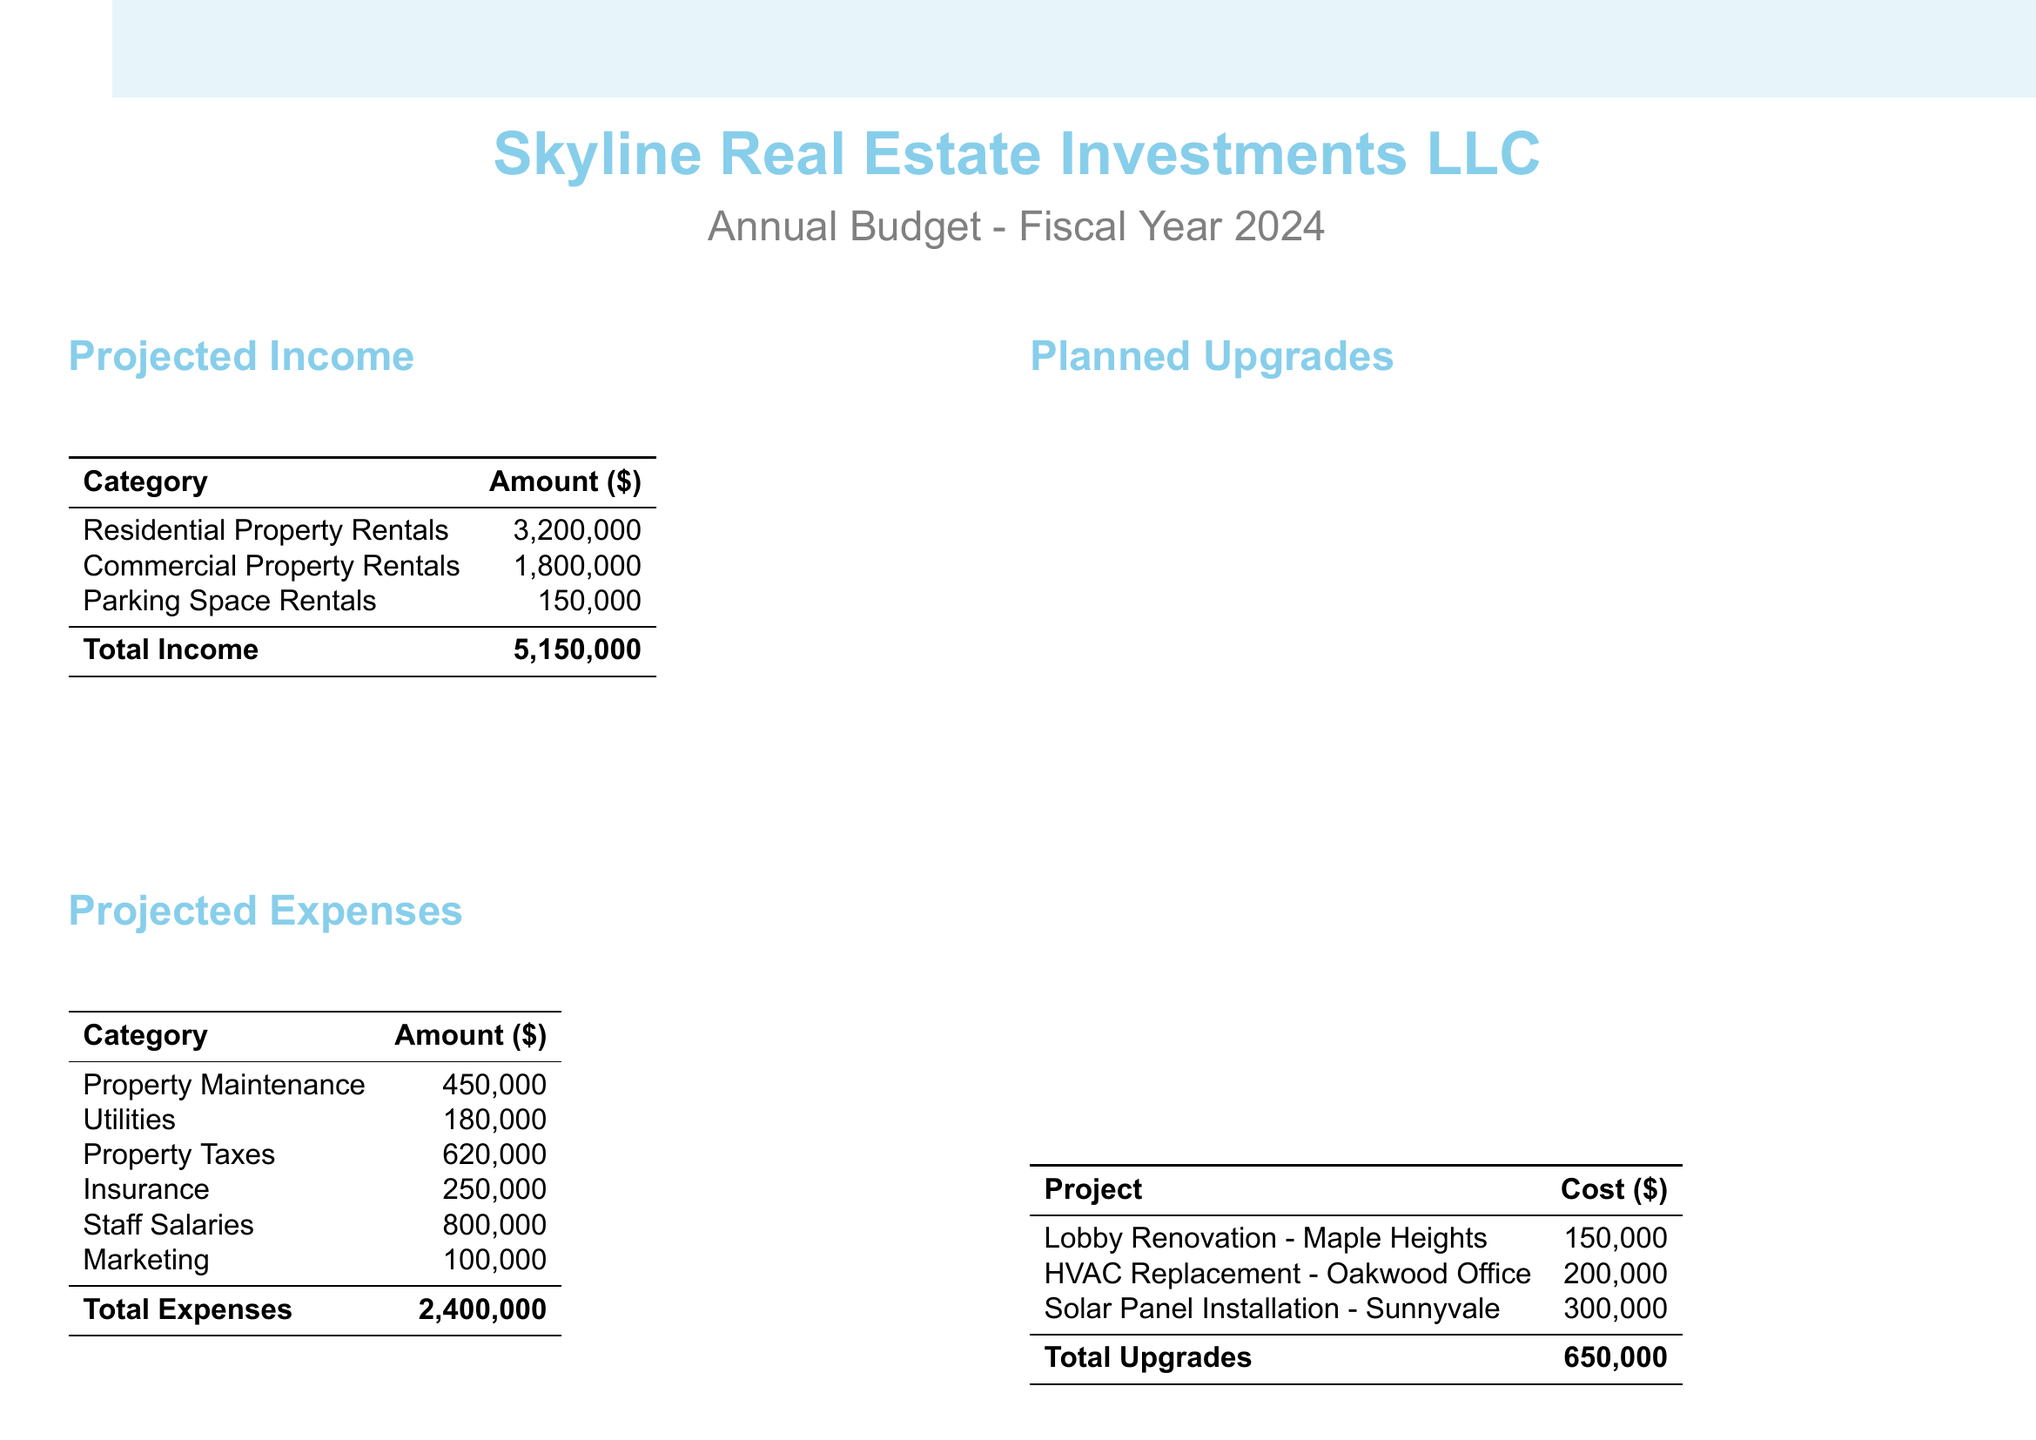What is the total income from residential property rentals? The total income from residential property rentals is stated clearly in the projected income section of the document.
Answer: 3,200,000 What is the total projected expenses for the fiscal year? The total projected expenses can be found at the end of the projected expenses section and summarizes all listed expenses.
Answer: 2,400,000 What is the cost of the HVAC replacement project? The cost for the HVAC replacement project is listed in the planned upgrades section of the document.
Answer: 200,000 What is the net income after planned upgrades? The net income is computed by subtracting total expenses and planned upgrades from total income, as outlined in the financial summary.
Answer: 2,100,000 What is the total amount for planned upgrades? The total amount for planned upgrades can be seen in the planned upgrades section at the end of the list of project costs.
Answer: 650,000 What are the total income from commercial property rentals? The total income from commercial property rentals is provided in the projected income section of the document.
Answer: 1,800,000 What is the total for property maintenance expenses? The expense amount for property maintenance is listed under projected expenses in the document.
Answer: 450,000 What metric is used to calculate Cash on Cash Return? The Cash on Cash Return is calculated as described in the key financial metrics section of the document.
Answer: Annual Cash Flow / Total Cash Invested 